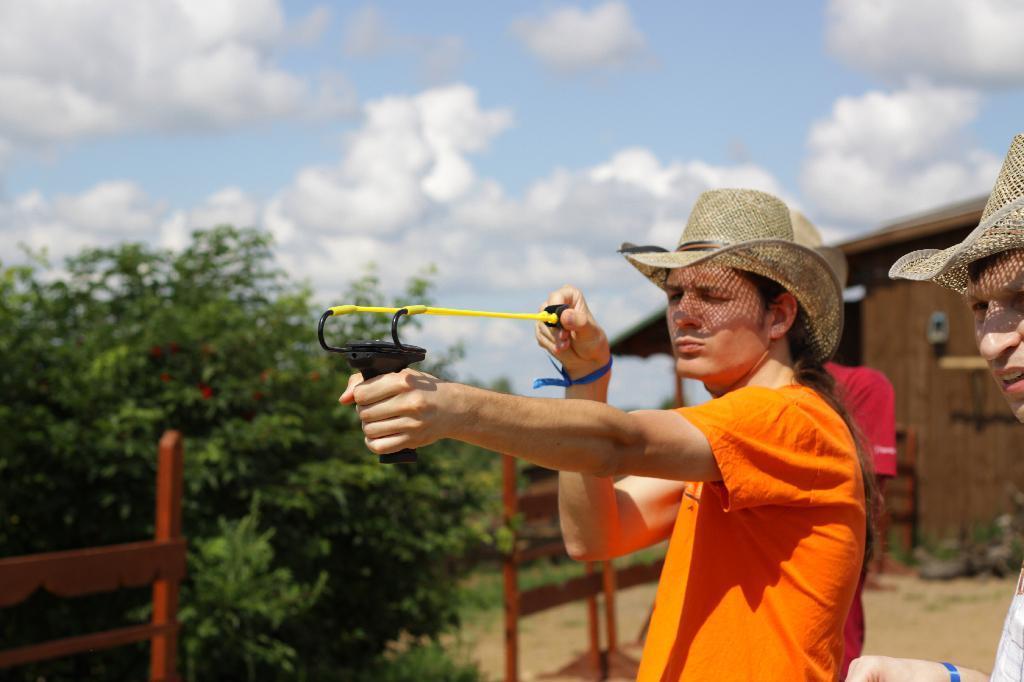Could you give a brief overview of what you see in this image? In this image we can see a person wearing a cap and holding an object in his hand. To the right side of the image there is another person wearing a cap. In the background of the image there is a wooden house, sky, clouds, trees. There is a wooden fencing. 